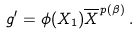Convert formula to latex. <formula><loc_0><loc_0><loc_500><loc_500>g ^ { \prime } = \phi ( X _ { 1 } ) \overline { X } ^ { p ( \beta ) } \, .</formula> 